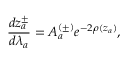<formula> <loc_0><loc_0><loc_500><loc_500>\frac { d z _ { a } ^ { \pm } } { d \lambda _ { a } } = A _ { a } ^ { ( \pm ) } e ^ { - 2 \rho ( z _ { a } ) } ,</formula> 